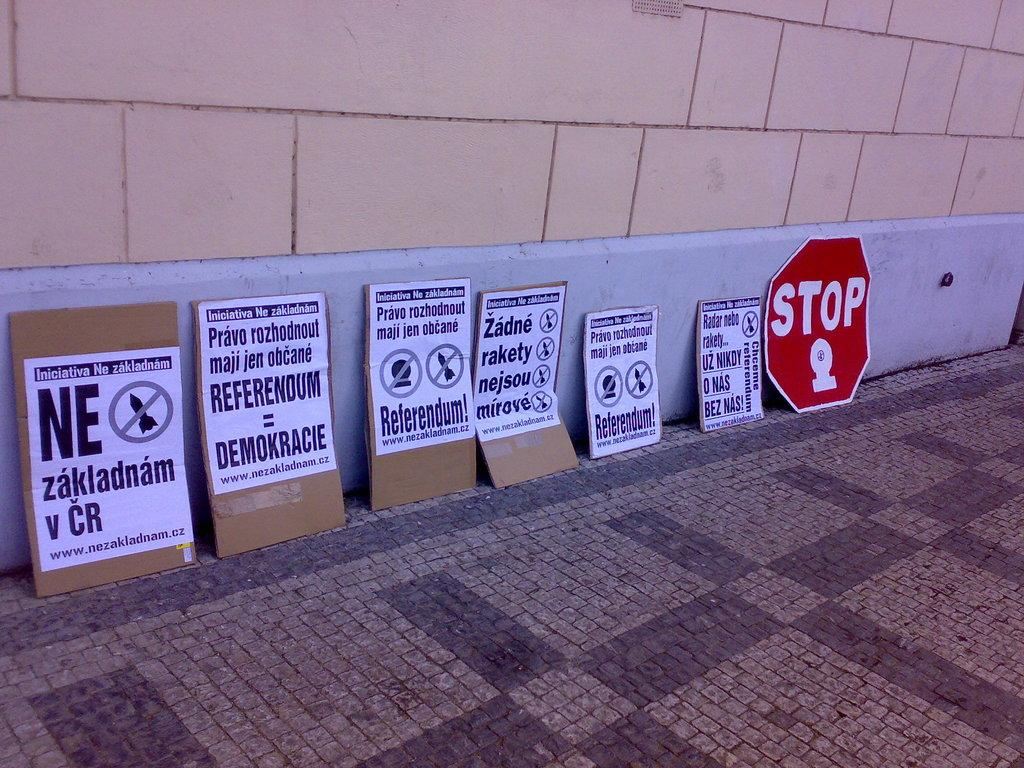<image>
Share a concise interpretation of the image provided. A row of cardboard signs are lined up on a sidewalk and one of them says Ne zakladnam v CR. 